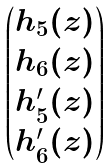<formula> <loc_0><loc_0><loc_500><loc_500>\begin{pmatrix} h _ { 5 } ( z ) \\ h _ { 6 } ( z ) \\ h _ { 5 } ^ { \prime } ( z ) \\ h _ { 6 } ^ { \prime } ( z ) \end{pmatrix}</formula> 